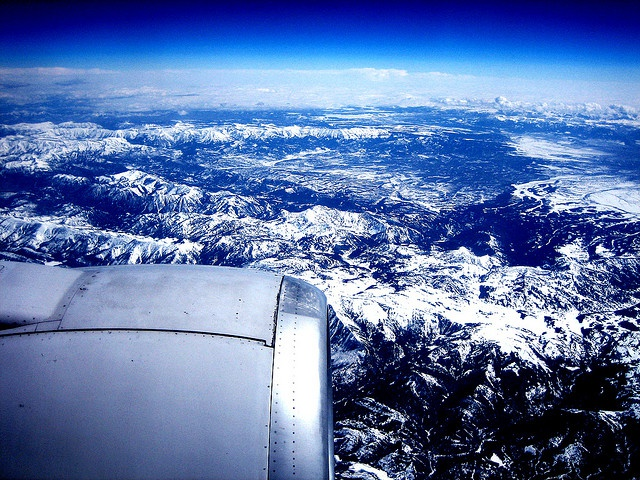Describe the objects in this image and their specific colors. I can see a airplane in black, darkgray, gray, and lavender tones in this image. 